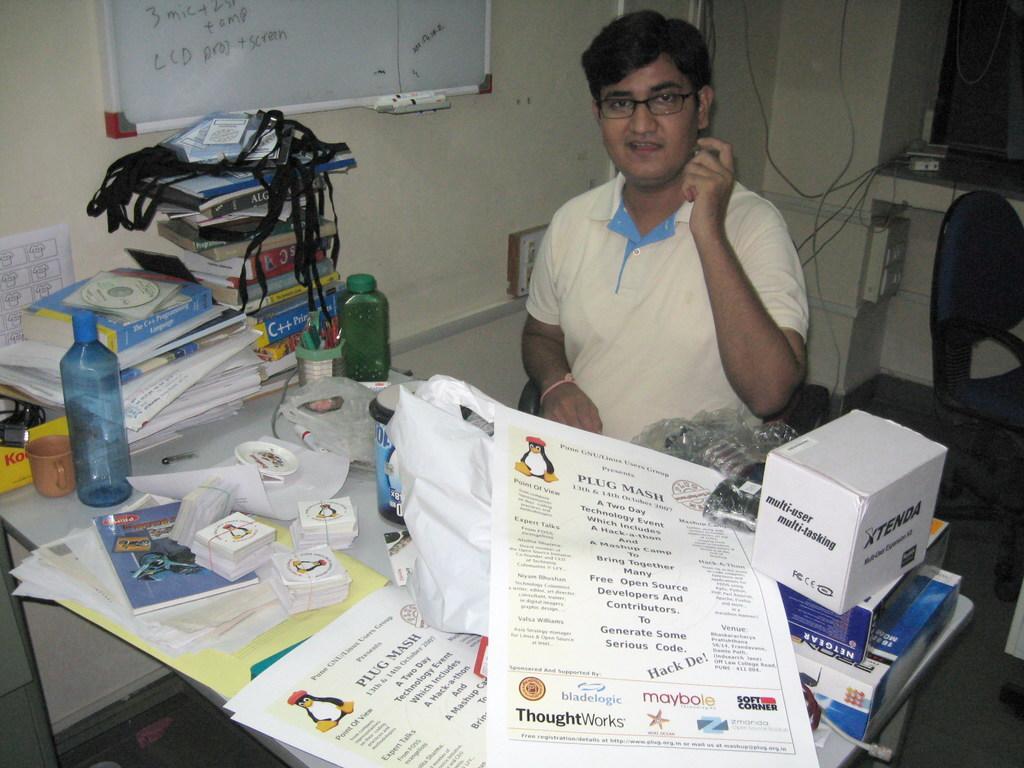Please provide a concise description of this image. In this picture I can see a man is sitting on the chair. On the table I can see bottles, books, papers, box and other objects on it. 